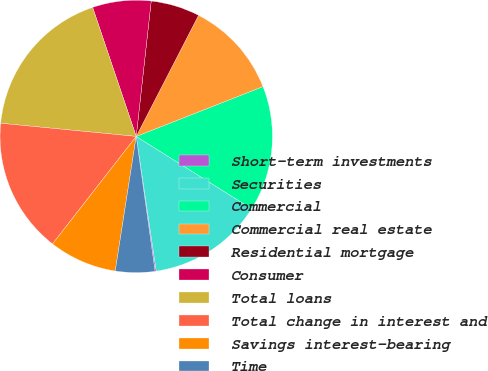Convert chart to OTSL. <chart><loc_0><loc_0><loc_500><loc_500><pie_chart><fcel>Short-term investments<fcel>Securities<fcel>Commercial<fcel>Commercial real estate<fcel>Residential mortgage<fcel>Consumer<fcel>Total loans<fcel>Total change in interest and<fcel>Savings interest-bearing<fcel>Time<nl><fcel>0.14%<fcel>13.74%<fcel>14.87%<fcel>11.47%<fcel>5.81%<fcel>6.94%<fcel>18.27%<fcel>16.01%<fcel>8.07%<fcel>4.67%<nl></chart> 